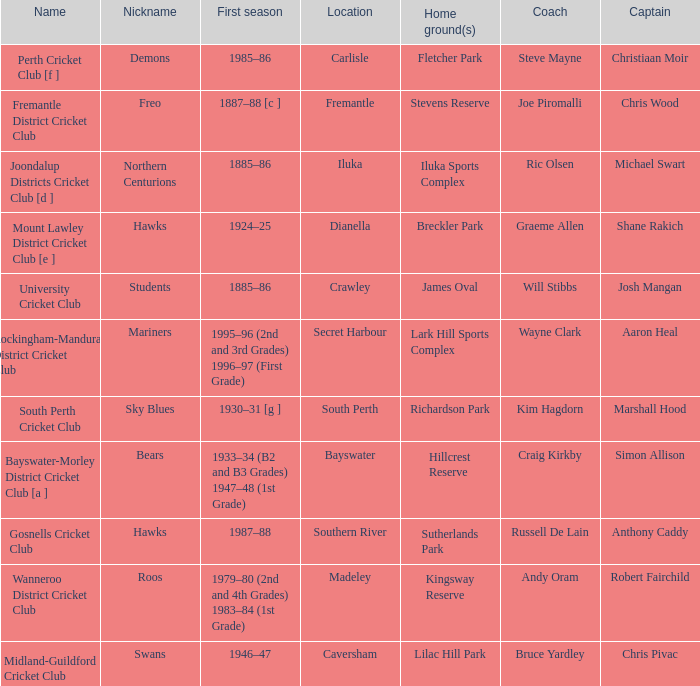What is the code nickname where Steve Mayne is the coach? Demons. 